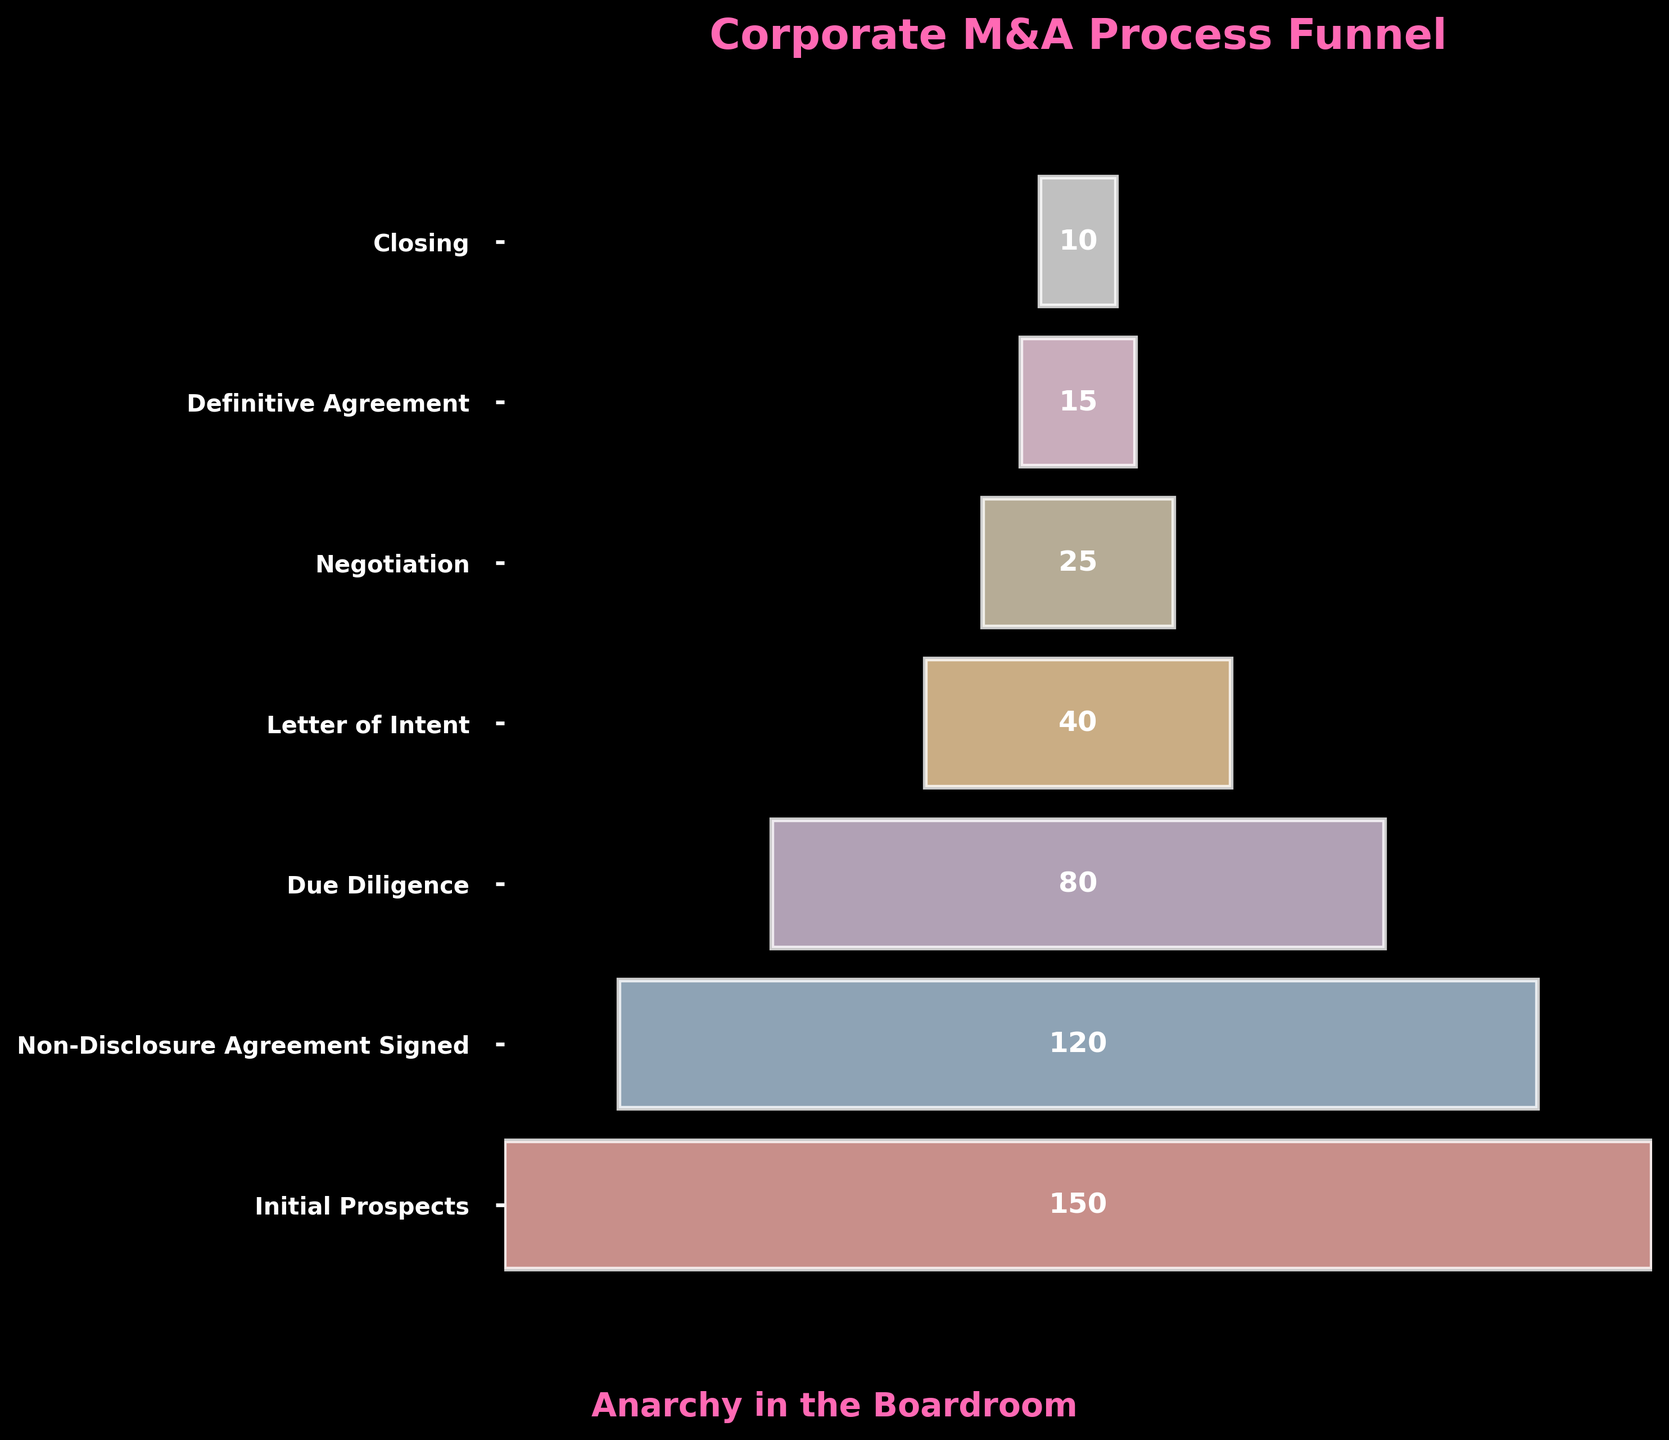What is the title of the figure? The title is written at the top of the figure and reads "Corporate M&A Process Funnel".
Answer: Corporate M&A Process Funnel How many stages are represented in the funnel? There are different horizontal bars for each stage of the process, each labeled with a stage name.
Answer: 7 Which stage has the highest count, and what is that count? The width of each bar represents the count, and the widest bar is labeled "Initial Prospects" with a count of 150.
Answer: Initial Prospects, 150 What is the count for the "Due Diligence" stage? The count is given as a label inside the bar at the "Due Diligence" stage.
Answer: 80 Which stage directly follows "Letter of Intent"? The stages are listed sequentially from top to bottom; "Negotiation" is the stage that directly follows "Letter of Intent".
Answer: Negotiation What is the difference in count between the "Initial Prospects" and "Definitive Agreement" stages? The count for "Initial Prospects" is 150 and for "Definitive Agreement" is 15; the difference is calculated as 150 - 15.
Answer: 135 What is the average count of all the stages in the process? To find the average, sum all counts (150 + 120 + 80 + 40 + 25 + 15 + 10) = 440 and divide by the number of stages (7), which is 440 / 7.
Answer: 62.86 Which stage has exactly half the count of the "Due Diligence" stage? The count for "Due Diligence" is 80. The stage with half of this count, which is 40, is "Letter of Intent".
Answer: Letter of Intent Which stage has the smallest number of companies, and what is that number? The thinnest bar represents the stage with the smallest count, which is "Closing" with a count of 10.
Answer: Closing, 10 